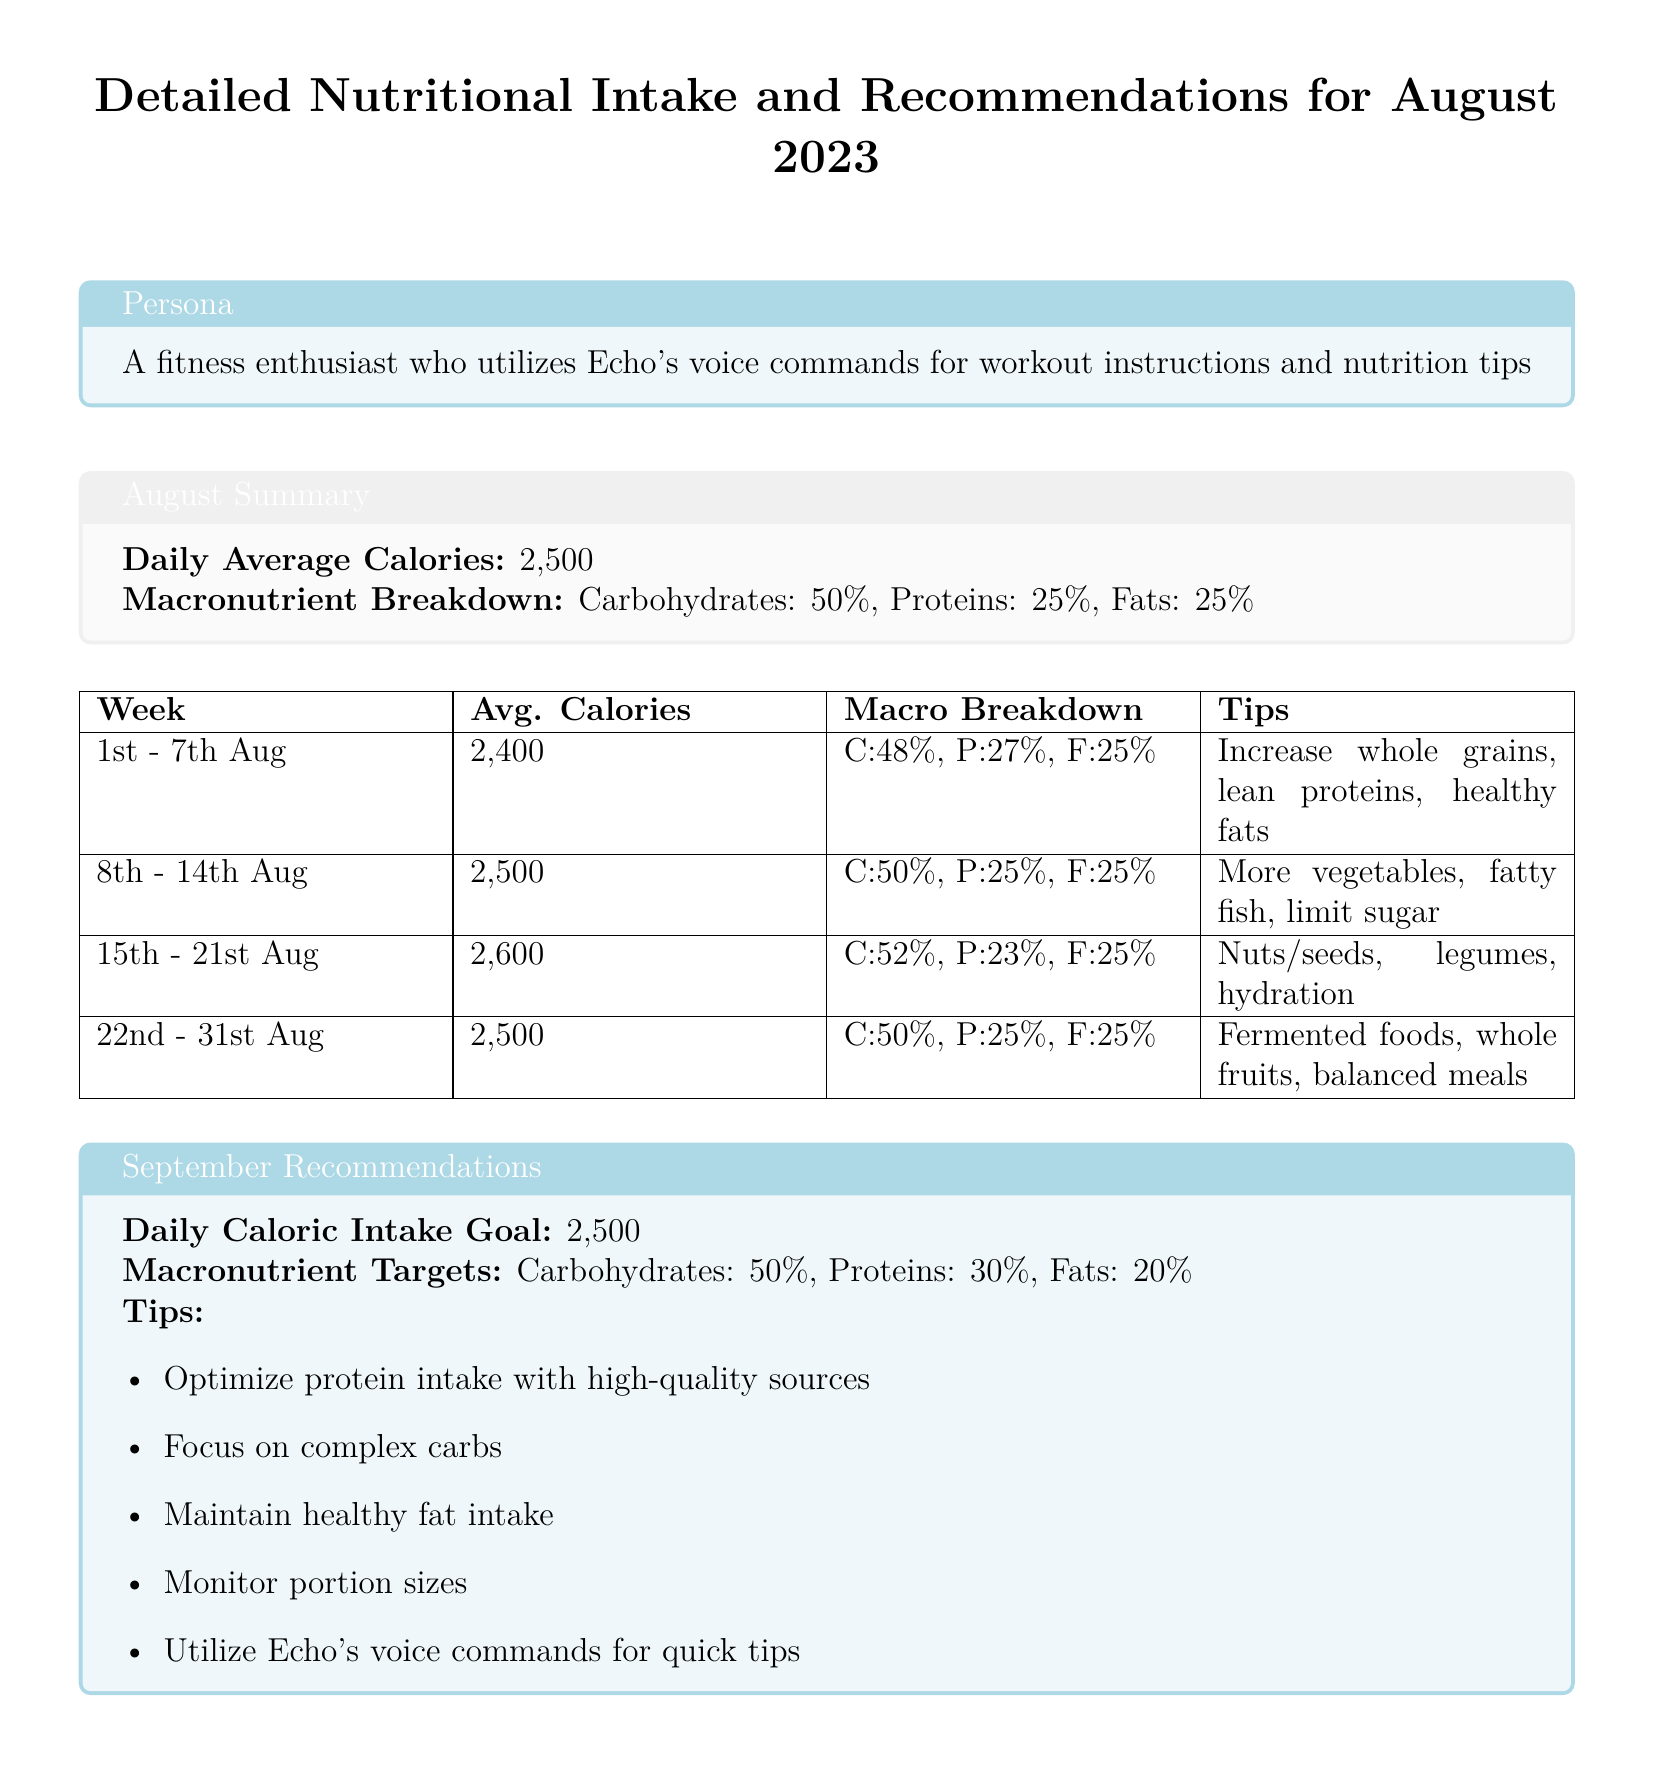what is the daily average calorie intake for August 2023? The daily average calorie intake for August 2023 is stated in the summary section of the document as 2,500.
Answer: 2,500 what is the macronutrient breakdown for August? The macronutrient breakdown for August 2023 indicates that carbohydrates are 50%, proteins are 25%, and fats are 25%.
Answer: Carbohydrates: 50%, Proteins: 25%, Fats: 25% what was the average caloric intake for the week of August 15th - 21st? The average caloric intake for the week of August 15th - 21st is listed in the table as 2,600.
Answer: 2,600 which week had the highest average calories? The week with the highest average calories is the week of August 15th - 21st, as indicated by the 2,600 average in the table.
Answer: 15th - 21st Aug what is one tip from the August recommendations? The tips for nutritional intake are summarized in the table, and one of the tips provided is "Increase whole grains, lean proteins, healthy fats."
Answer: Increase whole grains, lean proteins, healthy fats what is the caloric intake goal for September? The caloric intake goal for September is specified as 2,500 in the recommendations section.
Answer: 2,500 how are proteins distributed in the macronutrient targets for September? The macronutrient targets for September list proteins at 30% of the total intake.
Answer: 30% what type of foods are recommended to focus on for September? The recommendations include focusing on complex carbs as part of the dietary suggestions for September.
Answer: Complex carbs which nutrients does the document suggest optimizing for protein intake? The document does not specify exact nutrients but suggests using high-quality protein sources for optimizing protein intake.
Answer: High-quality sources 